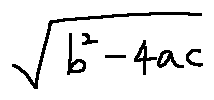Convert formula to latex. <formula><loc_0><loc_0><loc_500><loc_500>\sqrt { b ^ { 2 } - 4 a c }</formula> 